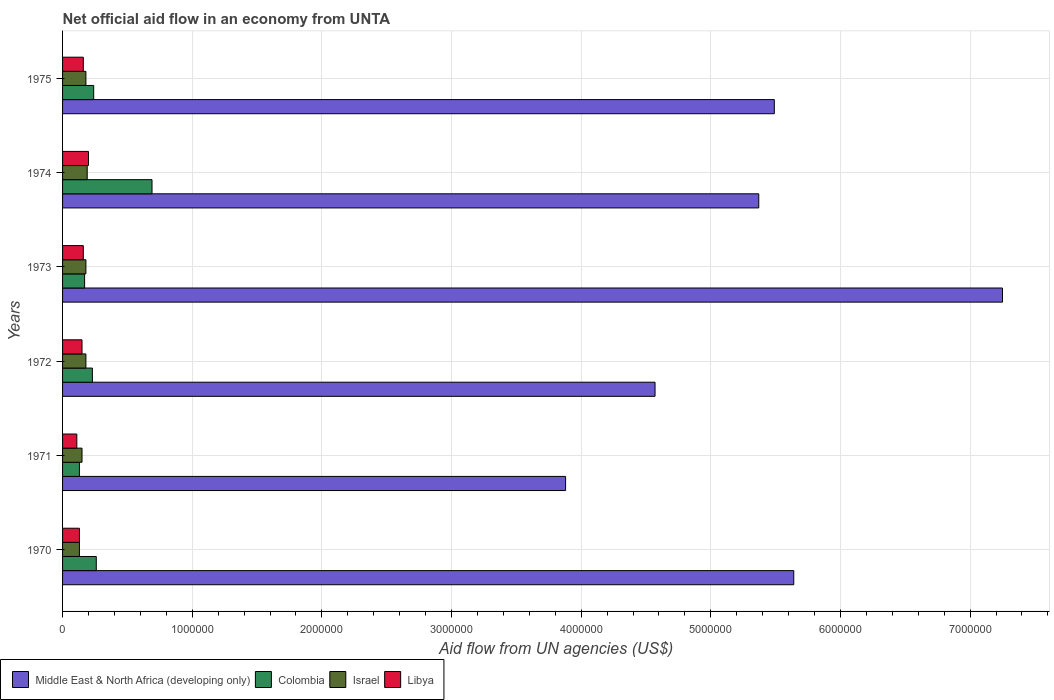Are the number of bars on each tick of the Y-axis equal?
Your response must be concise. Yes. How many bars are there on the 6th tick from the bottom?
Your response must be concise. 4. What is the net official aid flow in Israel in 1975?
Keep it short and to the point. 1.80e+05. Across all years, what is the maximum net official aid flow in Libya?
Provide a short and direct response. 2.00e+05. In which year was the net official aid flow in Libya maximum?
Make the answer very short. 1974. What is the total net official aid flow in Libya in the graph?
Offer a very short reply. 9.10e+05. What is the difference between the net official aid flow in Middle East & North Africa (developing only) in 1975 and the net official aid flow in Libya in 1972?
Your answer should be compact. 5.34e+06. What is the average net official aid flow in Middle East & North Africa (developing only) per year?
Make the answer very short. 5.37e+06. In how many years, is the net official aid flow in Colombia greater than 4200000 US$?
Offer a terse response. 0. What is the ratio of the net official aid flow in Israel in 1970 to that in 1971?
Offer a very short reply. 0.87. Is the difference between the net official aid flow in Libya in 1970 and 1972 greater than the difference between the net official aid flow in Israel in 1970 and 1972?
Make the answer very short. Yes. What is the difference between the highest and the lowest net official aid flow in Israel?
Keep it short and to the point. 6.00e+04. Is it the case that in every year, the sum of the net official aid flow in Colombia and net official aid flow in Israel is greater than the sum of net official aid flow in Middle East & North Africa (developing only) and net official aid flow in Libya?
Offer a terse response. No. What does the 4th bar from the top in 1971 represents?
Provide a succinct answer. Middle East & North Africa (developing only). What does the 4th bar from the bottom in 1974 represents?
Provide a short and direct response. Libya. Is it the case that in every year, the sum of the net official aid flow in Middle East & North Africa (developing only) and net official aid flow in Israel is greater than the net official aid flow in Colombia?
Give a very brief answer. Yes. Are all the bars in the graph horizontal?
Your answer should be compact. Yes. Are the values on the major ticks of X-axis written in scientific E-notation?
Keep it short and to the point. No. Does the graph contain any zero values?
Provide a short and direct response. No. Where does the legend appear in the graph?
Your response must be concise. Bottom left. How many legend labels are there?
Ensure brevity in your answer.  4. How are the legend labels stacked?
Provide a short and direct response. Horizontal. What is the title of the graph?
Make the answer very short. Net official aid flow in an economy from UNTA. Does "Puerto Rico" appear as one of the legend labels in the graph?
Make the answer very short. No. What is the label or title of the X-axis?
Provide a short and direct response. Aid flow from UN agencies (US$). What is the Aid flow from UN agencies (US$) in Middle East & North Africa (developing only) in 1970?
Your answer should be very brief. 5.64e+06. What is the Aid flow from UN agencies (US$) in Colombia in 1970?
Your response must be concise. 2.60e+05. What is the Aid flow from UN agencies (US$) of Libya in 1970?
Offer a terse response. 1.30e+05. What is the Aid flow from UN agencies (US$) of Middle East & North Africa (developing only) in 1971?
Offer a terse response. 3.88e+06. What is the Aid flow from UN agencies (US$) of Colombia in 1971?
Make the answer very short. 1.30e+05. What is the Aid flow from UN agencies (US$) of Middle East & North Africa (developing only) in 1972?
Offer a terse response. 4.57e+06. What is the Aid flow from UN agencies (US$) in Colombia in 1972?
Ensure brevity in your answer.  2.30e+05. What is the Aid flow from UN agencies (US$) in Israel in 1972?
Your response must be concise. 1.80e+05. What is the Aid flow from UN agencies (US$) in Middle East & North Africa (developing only) in 1973?
Your answer should be compact. 7.25e+06. What is the Aid flow from UN agencies (US$) in Colombia in 1973?
Offer a terse response. 1.70e+05. What is the Aid flow from UN agencies (US$) in Middle East & North Africa (developing only) in 1974?
Give a very brief answer. 5.37e+06. What is the Aid flow from UN agencies (US$) in Colombia in 1974?
Offer a very short reply. 6.90e+05. What is the Aid flow from UN agencies (US$) in Libya in 1974?
Give a very brief answer. 2.00e+05. What is the Aid flow from UN agencies (US$) in Middle East & North Africa (developing only) in 1975?
Your response must be concise. 5.49e+06. What is the Aid flow from UN agencies (US$) in Colombia in 1975?
Make the answer very short. 2.40e+05. What is the Aid flow from UN agencies (US$) of Libya in 1975?
Provide a short and direct response. 1.60e+05. Across all years, what is the maximum Aid flow from UN agencies (US$) in Middle East & North Africa (developing only)?
Your response must be concise. 7.25e+06. Across all years, what is the maximum Aid flow from UN agencies (US$) in Colombia?
Offer a very short reply. 6.90e+05. Across all years, what is the maximum Aid flow from UN agencies (US$) in Israel?
Give a very brief answer. 1.90e+05. Across all years, what is the minimum Aid flow from UN agencies (US$) of Middle East & North Africa (developing only)?
Offer a very short reply. 3.88e+06. Across all years, what is the minimum Aid flow from UN agencies (US$) in Israel?
Your answer should be compact. 1.30e+05. Across all years, what is the minimum Aid flow from UN agencies (US$) in Libya?
Your answer should be very brief. 1.10e+05. What is the total Aid flow from UN agencies (US$) in Middle East & North Africa (developing only) in the graph?
Offer a very short reply. 3.22e+07. What is the total Aid flow from UN agencies (US$) in Colombia in the graph?
Your response must be concise. 1.72e+06. What is the total Aid flow from UN agencies (US$) in Israel in the graph?
Your response must be concise. 1.01e+06. What is the total Aid flow from UN agencies (US$) of Libya in the graph?
Keep it short and to the point. 9.10e+05. What is the difference between the Aid flow from UN agencies (US$) of Middle East & North Africa (developing only) in 1970 and that in 1971?
Your answer should be very brief. 1.76e+06. What is the difference between the Aid flow from UN agencies (US$) in Libya in 1970 and that in 1971?
Keep it short and to the point. 2.00e+04. What is the difference between the Aid flow from UN agencies (US$) of Middle East & North Africa (developing only) in 1970 and that in 1972?
Keep it short and to the point. 1.07e+06. What is the difference between the Aid flow from UN agencies (US$) in Colombia in 1970 and that in 1972?
Provide a succinct answer. 3.00e+04. What is the difference between the Aid flow from UN agencies (US$) in Israel in 1970 and that in 1972?
Make the answer very short. -5.00e+04. What is the difference between the Aid flow from UN agencies (US$) of Libya in 1970 and that in 1972?
Ensure brevity in your answer.  -2.00e+04. What is the difference between the Aid flow from UN agencies (US$) of Middle East & North Africa (developing only) in 1970 and that in 1973?
Your answer should be very brief. -1.61e+06. What is the difference between the Aid flow from UN agencies (US$) of Colombia in 1970 and that in 1973?
Your response must be concise. 9.00e+04. What is the difference between the Aid flow from UN agencies (US$) of Libya in 1970 and that in 1973?
Your answer should be compact. -3.00e+04. What is the difference between the Aid flow from UN agencies (US$) of Middle East & North Africa (developing only) in 1970 and that in 1974?
Offer a very short reply. 2.70e+05. What is the difference between the Aid flow from UN agencies (US$) in Colombia in 1970 and that in 1974?
Your answer should be compact. -4.30e+05. What is the difference between the Aid flow from UN agencies (US$) in Israel in 1970 and that in 1974?
Your response must be concise. -6.00e+04. What is the difference between the Aid flow from UN agencies (US$) in Libya in 1970 and that in 1974?
Offer a very short reply. -7.00e+04. What is the difference between the Aid flow from UN agencies (US$) in Middle East & North Africa (developing only) in 1970 and that in 1975?
Offer a very short reply. 1.50e+05. What is the difference between the Aid flow from UN agencies (US$) in Colombia in 1970 and that in 1975?
Give a very brief answer. 2.00e+04. What is the difference between the Aid flow from UN agencies (US$) in Libya in 1970 and that in 1975?
Offer a terse response. -3.00e+04. What is the difference between the Aid flow from UN agencies (US$) of Middle East & North Africa (developing only) in 1971 and that in 1972?
Provide a succinct answer. -6.90e+05. What is the difference between the Aid flow from UN agencies (US$) of Libya in 1971 and that in 1972?
Provide a succinct answer. -4.00e+04. What is the difference between the Aid flow from UN agencies (US$) of Middle East & North Africa (developing only) in 1971 and that in 1973?
Ensure brevity in your answer.  -3.37e+06. What is the difference between the Aid flow from UN agencies (US$) of Middle East & North Africa (developing only) in 1971 and that in 1974?
Ensure brevity in your answer.  -1.49e+06. What is the difference between the Aid flow from UN agencies (US$) in Colombia in 1971 and that in 1974?
Your answer should be very brief. -5.60e+05. What is the difference between the Aid flow from UN agencies (US$) of Middle East & North Africa (developing only) in 1971 and that in 1975?
Offer a terse response. -1.61e+06. What is the difference between the Aid flow from UN agencies (US$) in Middle East & North Africa (developing only) in 1972 and that in 1973?
Make the answer very short. -2.68e+06. What is the difference between the Aid flow from UN agencies (US$) of Colombia in 1972 and that in 1973?
Ensure brevity in your answer.  6.00e+04. What is the difference between the Aid flow from UN agencies (US$) of Israel in 1972 and that in 1973?
Your answer should be compact. 0. What is the difference between the Aid flow from UN agencies (US$) in Libya in 1972 and that in 1973?
Your answer should be very brief. -10000. What is the difference between the Aid flow from UN agencies (US$) of Middle East & North Africa (developing only) in 1972 and that in 1974?
Offer a terse response. -8.00e+05. What is the difference between the Aid flow from UN agencies (US$) in Colombia in 1972 and that in 1974?
Offer a terse response. -4.60e+05. What is the difference between the Aid flow from UN agencies (US$) in Israel in 1972 and that in 1974?
Your answer should be compact. -10000. What is the difference between the Aid flow from UN agencies (US$) in Middle East & North Africa (developing only) in 1972 and that in 1975?
Offer a terse response. -9.20e+05. What is the difference between the Aid flow from UN agencies (US$) in Colombia in 1972 and that in 1975?
Give a very brief answer. -10000. What is the difference between the Aid flow from UN agencies (US$) of Middle East & North Africa (developing only) in 1973 and that in 1974?
Offer a terse response. 1.88e+06. What is the difference between the Aid flow from UN agencies (US$) in Colombia in 1973 and that in 1974?
Your answer should be very brief. -5.20e+05. What is the difference between the Aid flow from UN agencies (US$) in Libya in 1973 and that in 1974?
Give a very brief answer. -4.00e+04. What is the difference between the Aid flow from UN agencies (US$) in Middle East & North Africa (developing only) in 1973 and that in 1975?
Your response must be concise. 1.76e+06. What is the difference between the Aid flow from UN agencies (US$) in Libya in 1974 and that in 1975?
Ensure brevity in your answer.  4.00e+04. What is the difference between the Aid flow from UN agencies (US$) of Middle East & North Africa (developing only) in 1970 and the Aid flow from UN agencies (US$) of Colombia in 1971?
Offer a terse response. 5.51e+06. What is the difference between the Aid flow from UN agencies (US$) of Middle East & North Africa (developing only) in 1970 and the Aid flow from UN agencies (US$) of Israel in 1971?
Make the answer very short. 5.49e+06. What is the difference between the Aid flow from UN agencies (US$) in Middle East & North Africa (developing only) in 1970 and the Aid flow from UN agencies (US$) in Libya in 1971?
Your response must be concise. 5.53e+06. What is the difference between the Aid flow from UN agencies (US$) in Israel in 1970 and the Aid flow from UN agencies (US$) in Libya in 1971?
Your answer should be very brief. 2.00e+04. What is the difference between the Aid flow from UN agencies (US$) in Middle East & North Africa (developing only) in 1970 and the Aid flow from UN agencies (US$) in Colombia in 1972?
Give a very brief answer. 5.41e+06. What is the difference between the Aid flow from UN agencies (US$) of Middle East & North Africa (developing only) in 1970 and the Aid flow from UN agencies (US$) of Israel in 1972?
Offer a very short reply. 5.46e+06. What is the difference between the Aid flow from UN agencies (US$) in Middle East & North Africa (developing only) in 1970 and the Aid flow from UN agencies (US$) in Libya in 1972?
Your response must be concise. 5.49e+06. What is the difference between the Aid flow from UN agencies (US$) in Israel in 1970 and the Aid flow from UN agencies (US$) in Libya in 1972?
Provide a succinct answer. -2.00e+04. What is the difference between the Aid flow from UN agencies (US$) of Middle East & North Africa (developing only) in 1970 and the Aid flow from UN agencies (US$) of Colombia in 1973?
Your response must be concise. 5.47e+06. What is the difference between the Aid flow from UN agencies (US$) in Middle East & North Africa (developing only) in 1970 and the Aid flow from UN agencies (US$) in Israel in 1973?
Keep it short and to the point. 5.46e+06. What is the difference between the Aid flow from UN agencies (US$) of Middle East & North Africa (developing only) in 1970 and the Aid flow from UN agencies (US$) of Libya in 1973?
Offer a terse response. 5.48e+06. What is the difference between the Aid flow from UN agencies (US$) of Colombia in 1970 and the Aid flow from UN agencies (US$) of Libya in 1973?
Make the answer very short. 1.00e+05. What is the difference between the Aid flow from UN agencies (US$) of Middle East & North Africa (developing only) in 1970 and the Aid flow from UN agencies (US$) of Colombia in 1974?
Make the answer very short. 4.95e+06. What is the difference between the Aid flow from UN agencies (US$) of Middle East & North Africa (developing only) in 1970 and the Aid flow from UN agencies (US$) of Israel in 1974?
Offer a terse response. 5.45e+06. What is the difference between the Aid flow from UN agencies (US$) of Middle East & North Africa (developing only) in 1970 and the Aid flow from UN agencies (US$) of Libya in 1974?
Give a very brief answer. 5.44e+06. What is the difference between the Aid flow from UN agencies (US$) of Colombia in 1970 and the Aid flow from UN agencies (US$) of Libya in 1974?
Provide a short and direct response. 6.00e+04. What is the difference between the Aid flow from UN agencies (US$) of Middle East & North Africa (developing only) in 1970 and the Aid flow from UN agencies (US$) of Colombia in 1975?
Ensure brevity in your answer.  5.40e+06. What is the difference between the Aid flow from UN agencies (US$) of Middle East & North Africa (developing only) in 1970 and the Aid flow from UN agencies (US$) of Israel in 1975?
Keep it short and to the point. 5.46e+06. What is the difference between the Aid flow from UN agencies (US$) in Middle East & North Africa (developing only) in 1970 and the Aid flow from UN agencies (US$) in Libya in 1975?
Make the answer very short. 5.48e+06. What is the difference between the Aid flow from UN agencies (US$) of Colombia in 1970 and the Aid flow from UN agencies (US$) of Libya in 1975?
Your answer should be compact. 1.00e+05. What is the difference between the Aid flow from UN agencies (US$) of Israel in 1970 and the Aid flow from UN agencies (US$) of Libya in 1975?
Keep it short and to the point. -3.00e+04. What is the difference between the Aid flow from UN agencies (US$) of Middle East & North Africa (developing only) in 1971 and the Aid flow from UN agencies (US$) of Colombia in 1972?
Your answer should be compact. 3.65e+06. What is the difference between the Aid flow from UN agencies (US$) in Middle East & North Africa (developing only) in 1971 and the Aid flow from UN agencies (US$) in Israel in 1972?
Your response must be concise. 3.70e+06. What is the difference between the Aid flow from UN agencies (US$) in Middle East & North Africa (developing only) in 1971 and the Aid flow from UN agencies (US$) in Libya in 1972?
Ensure brevity in your answer.  3.73e+06. What is the difference between the Aid flow from UN agencies (US$) in Colombia in 1971 and the Aid flow from UN agencies (US$) in Israel in 1972?
Your answer should be very brief. -5.00e+04. What is the difference between the Aid flow from UN agencies (US$) in Colombia in 1971 and the Aid flow from UN agencies (US$) in Libya in 1972?
Offer a terse response. -2.00e+04. What is the difference between the Aid flow from UN agencies (US$) of Middle East & North Africa (developing only) in 1971 and the Aid flow from UN agencies (US$) of Colombia in 1973?
Provide a short and direct response. 3.71e+06. What is the difference between the Aid flow from UN agencies (US$) of Middle East & North Africa (developing only) in 1971 and the Aid flow from UN agencies (US$) of Israel in 1973?
Your answer should be very brief. 3.70e+06. What is the difference between the Aid flow from UN agencies (US$) of Middle East & North Africa (developing only) in 1971 and the Aid flow from UN agencies (US$) of Libya in 1973?
Your answer should be very brief. 3.72e+06. What is the difference between the Aid flow from UN agencies (US$) in Israel in 1971 and the Aid flow from UN agencies (US$) in Libya in 1973?
Give a very brief answer. -10000. What is the difference between the Aid flow from UN agencies (US$) in Middle East & North Africa (developing only) in 1971 and the Aid flow from UN agencies (US$) in Colombia in 1974?
Provide a succinct answer. 3.19e+06. What is the difference between the Aid flow from UN agencies (US$) of Middle East & North Africa (developing only) in 1971 and the Aid flow from UN agencies (US$) of Israel in 1974?
Provide a short and direct response. 3.69e+06. What is the difference between the Aid flow from UN agencies (US$) in Middle East & North Africa (developing only) in 1971 and the Aid flow from UN agencies (US$) in Libya in 1974?
Make the answer very short. 3.68e+06. What is the difference between the Aid flow from UN agencies (US$) in Colombia in 1971 and the Aid flow from UN agencies (US$) in Libya in 1974?
Give a very brief answer. -7.00e+04. What is the difference between the Aid flow from UN agencies (US$) in Israel in 1971 and the Aid flow from UN agencies (US$) in Libya in 1974?
Make the answer very short. -5.00e+04. What is the difference between the Aid flow from UN agencies (US$) of Middle East & North Africa (developing only) in 1971 and the Aid flow from UN agencies (US$) of Colombia in 1975?
Make the answer very short. 3.64e+06. What is the difference between the Aid flow from UN agencies (US$) of Middle East & North Africa (developing only) in 1971 and the Aid flow from UN agencies (US$) of Israel in 1975?
Give a very brief answer. 3.70e+06. What is the difference between the Aid flow from UN agencies (US$) of Middle East & North Africa (developing only) in 1971 and the Aid flow from UN agencies (US$) of Libya in 1975?
Your response must be concise. 3.72e+06. What is the difference between the Aid flow from UN agencies (US$) in Colombia in 1971 and the Aid flow from UN agencies (US$) in Libya in 1975?
Provide a short and direct response. -3.00e+04. What is the difference between the Aid flow from UN agencies (US$) in Israel in 1971 and the Aid flow from UN agencies (US$) in Libya in 1975?
Keep it short and to the point. -10000. What is the difference between the Aid flow from UN agencies (US$) in Middle East & North Africa (developing only) in 1972 and the Aid flow from UN agencies (US$) in Colombia in 1973?
Make the answer very short. 4.40e+06. What is the difference between the Aid flow from UN agencies (US$) in Middle East & North Africa (developing only) in 1972 and the Aid flow from UN agencies (US$) in Israel in 1973?
Offer a very short reply. 4.39e+06. What is the difference between the Aid flow from UN agencies (US$) of Middle East & North Africa (developing only) in 1972 and the Aid flow from UN agencies (US$) of Libya in 1973?
Offer a terse response. 4.41e+06. What is the difference between the Aid flow from UN agencies (US$) in Colombia in 1972 and the Aid flow from UN agencies (US$) in Israel in 1973?
Your answer should be very brief. 5.00e+04. What is the difference between the Aid flow from UN agencies (US$) in Colombia in 1972 and the Aid flow from UN agencies (US$) in Libya in 1973?
Offer a terse response. 7.00e+04. What is the difference between the Aid flow from UN agencies (US$) in Middle East & North Africa (developing only) in 1972 and the Aid flow from UN agencies (US$) in Colombia in 1974?
Provide a succinct answer. 3.88e+06. What is the difference between the Aid flow from UN agencies (US$) of Middle East & North Africa (developing only) in 1972 and the Aid flow from UN agencies (US$) of Israel in 1974?
Provide a succinct answer. 4.38e+06. What is the difference between the Aid flow from UN agencies (US$) of Middle East & North Africa (developing only) in 1972 and the Aid flow from UN agencies (US$) of Libya in 1974?
Make the answer very short. 4.37e+06. What is the difference between the Aid flow from UN agencies (US$) of Colombia in 1972 and the Aid flow from UN agencies (US$) of Libya in 1974?
Make the answer very short. 3.00e+04. What is the difference between the Aid flow from UN agencies (US$) of Middle East & North Africa (developing only) in 1972 and the Aid flow from UN agencies (US$) of Colombia in 1975?
Keep it short and to the point. 4.33e+06. What is the difference between the Aid flow from UN agencies (US$) in Middle East & North Africa (developing only) in 1972 and the Aid flow from UN agencies (US$) in Israel in 1975?
Provide a short and direct response. 4.39e+06. What is the difference between the Aid flow from UN agencies (US$) in Middle East & North Africa (developing only) in 1972 and the Aid flow from UN agencies (US$) in Libya in 1975?
Give a very brief answer. 4.41e+06. What is the difference between the Aid flow from UN agencies (US$) in Colombia in 1972 and the Aid flow from UN agencies (US$) in Israel in 1975?
Keep it short and to the point. 5.00e+04. What is the difference between the Aid flow from UN agencies (US$) in Colombia in 1972 and the Aid flow from UN agencies (US$) in Libya in 1975?
Keep it short and to the point. 7.00e+04. What is the difference between the Aid flow from UN agencies (US$) in Israel in 1972 and the Aid flow from UN agencies (US$) in Libya in 1975?
Offer a terse response. 2.00e+04. What is the difference between the Aid flow from UN agencies (US$) of Middle East & North Africa (developing only) in 1973 and the Aid flow from UN agencies (US$) of Colombia in 1974?
Ensure brevity in your answer.  6.56e+06. What is the difference between the Aid flow from UN agencies (US$) in Middle East & North Africa (developing only) in 1973 and the Aid flow from UN agencies (US$) in Israel in 1974?
Your response must be concise. 7.06e+06. What is the difference between the Aid flow from UN agencies (US$) of Middle East & North Africa (developing only) in 1973 and the Aid flow from UN agencies (US$) of Libya in 1974?
Give a very brief answer. 7.05e+06. What is the difference between the Aid flow from UN agencies (US$) in Colombia in 1973 and the Aid flow from UN agencies (US$) in Israel in 1974?
Give a very brief answer. -2.00e+04. What is the difference between the Aid flow from UN agencies (US$) in Colombia in 1973 and the Aid flow from UN agencies (US$) in Libya in 1974?
Keep it short and to the point. -3.00e+04. What is the difference between the Aid flow from UN agencies (US$) of Israel in 1973 and the Aid flow from UN agencies (US$) of Libya in 1974?
Offer a very short reply. -2.00e+04. What is the difference between the Aid flow from UN agencies (US$) of Middle East & North Africa (developing only) in 1973 and the Aid flow from UN agencies (US$) of Colombia in 1975?
Your answer should be very brief. 7.01e+06. What is the difference between the Aid flow from UN agencies (US$) in Middle East & North Africa (developing only) in 1973 and the Aid flow from UN agencies (US$) in Israel in 1975?
Make the answer very short. 7.07e+06. What is the difference between the Aid flow from UN agencies (US$) in Middle East & North Africa (developing only) in 1973 and the Aid flow from UN agencies (US$) in Libya in 1975?
Offer a terse response. 7.09e+06. What is the difference between the Aid flow from UN agencies (US$) in Israel in 1973 and the Aid flow from UN agencies (US$) in Libya in 1975?
Offer a terse response. 2.00e+04. What is the difference between the Aid flow from UN agencies (US$) of Middle East & North Africa (developing only) in 1974 and the Aid flow from UN agencies (US$) of Colombia in 1975?
Your answer should be very brief. 5.13e+06. What is the difference between the Aid flow from UN agencies (US$) of Middle East & North Africa (developing only) in 1974 and the Aid flow from UN agencies (US$) of Israel in 1975?
Ensure brevity in your answer.  5.19e+06. What is the difference between the Aid flow from UN agencies (US$) in Middle East & North Africa (developing only) in 1974 and the Aid flow from UN agencies (US$) in Libya in 1975?
Keep it short and to the point. 5.21e+06. What is the difference between the Aid flow from UN agencies (US$) in Colombia in 1974 and the Aid flow from UN agencies (US$) in Israel in 1975?
Your answer should be very brief. 5.10e+05. What is the difference between the Aid flow from UN agencies (US$) in Colombia in 1974 and the Aid flow from UN agencies (US$) in Libya in 1975?
Your response must be concise. 5.30e+05. What is the average Aid flow from UN agencies (US$) in Middle East & North Africa (developing only) per year?
Your response must be concise. 5.37e+06. What is the average Aid flow from UN agencies (US$) of Colombia per year?
Provide a short and direct response. 2.87e+05. What is the average Aid flow from UN agencies (US$) of Israel per year?
Provide a succinct answer. 1.68e+05. What is the average Aid flow from UN agencies (US$) in Libya per year?
Ensure brevity in your answer.  1.52e+05. In the year 1970, what is the difference between the Aid flow from UN agencies (US$) of Middle East & North Africa (developing only) and Aid flow from UN agencies (US$) of Colombia?
Provide a short and direct response. 5.38e+06. In the year 1970, what is the difference between the Aid flow from UN agencies (US$) in Middle East & North Africa (developing only) and Aid flow from UN agencies (US$) in Israel?
Your answer should be very brief. 5.51e+06. In the year 1970, what is the difference between the Aid flow from UN agencies (US$) of Middle East & North Africa (developing only) and Aid flow from UN agencies (US$) of Libya?
Your response must be concise. 5.51e+06. In the year 1970, what is the difference between the Aid flow from UN agencies (US$) of Colombia and Aid flow from UN agencies (US$) of Israel?
Your answer should be very brief. 1.30e+05. In the year 1970, what is the difference between the Aid flow from UN agencies (US$) in Colombia and Aid flow from UN agencies (US$) in Libya?
Provide a short and direct response. 1.30e+05. In the year 1970, what is the difference between the Aid flow from UN agencies (US$) of Israel and Aid flow from UN agencies (US$) of Libya?
Provide a succinct answer. 0. In the year 1971, what is the difference between the Aid flow from UN agencies (US$) in Middle East & North Africa (developing only) and Aid flow from UN agencies (US$) in Colombia?
Offer a very short reply. 3.75e+06. In the year 1971, what is the difference between the Aid flow from UN agencies (US$) of Middle East & North Africa (developing only) and Aid flow from UN agencies (US$) of Israel?
Provide a short and direct response. 3.73e+06. In the year 1971, what is the difference between the Aid flow from UN agencies (US$) of Middle East & North Africa (developing only) and Aid flow from UN agencies (US$) of Libya?
Your answer should be compact. 3.77e+06. In the year 1971, what is the difference between the Aid flow from UN agencies (US$) in Colombia and Aid flow from UN agencies (US$) in Israel?
Ensure brevity in your answer.  -2.00e+04. In the year 1971, what is the difference between the Aid flow from UN agencies (US$) in Colombia and Aid flow from UN agencies (US$) in Libya?
Your answer should be very brief. 2.00e+04. In the year 1971, what is the difference between the Aid flow from UN agencies (US$) in Israel and Aid flow from UN agencies (US$) in Libya?
Provide a short and direct response. 4.00e+04. In the year 1972, what is the difference between the Aid flow from UN agencies (US$) in Middle East & North Africa (developing only) and Aid flow from UN agencies (US$) in Colombia?
Provide a short and direct response. 4.34e+06. In the year 1972, what is the difference between the Aid flow from UN agencies (US$) of Middle East & North Africa (developing only) and Aid flow from UN agencies (US$) of Israel?
Offer a terse response. 4.39e+06. In the year 1972, what is the difference between the Aid flow from UN agencies (US$) of Middle East & North Africa (developing only) and Aid flow from UN agencies (US$) of Libya?
Your answer should be very brief. 4.42e+06. In the year 1972, what is the difference between the Aid flow from UN agencies (US$) in Colombia and Aid flow from UN agencies (US$) in Israel?
Give a very brief answer. 5.00e+04. In the year 1972, what is the difference between the Aid flow from UN agencies (US$) of Israel and Aid flow from UN agencies (US$) of Libya?
Offer a very short reply. 3.00e+04. In the year 1973, what is the difference between the Aid flow from UN agencies (US$) in Middle East & North Africa (developing only) and Aid flow from UN agencies (US$) in Colombia?
Your response must be concise. 7.08e+06. In the year 1973, what is the difference between the Aid flow from UN agencies (US$) of Middle East & North Africa (developing only) and Aid flow from UN agencies (US$) of Israel?
Make the answer very short. 7.07e+06. In the year 1973, what is the difference between the Aid flow from UN agencies (US$) in Middle East & North Africa (developing only) and Aid flow from UN agencies (US$) in Libya?
Provide a short and direct response. 7.09e+06. In the year 1973, what is the difference between the Aid flow from UN agencies (US$) in Israel and Aid flow from UN agencies (US$) in Libya?
Your answer should be very brief. 2.00e+04. In the year 1974, what is the difference between the Aid flow from UN agencies (US$) of Middle East & North Africa (developing only) and Aid flow from UN agencies (US$) of Colombia?
Give a very brief answer. 4.68e+06. In the year 1974, what is the difference between the Aid flow from UN agencies (US$) in Middle East & North Africa (developing only) and Aid flow from UN agencies (US$) in Israel?
Keep it short and to the point. 5.18e+06. In the year 1974, what is the difference between the Aid flow from UN agencies (US$) of Middle East & North Africa (developing only) and Aid flow from UN agencies (US$) of Libya?
Your answer should be very brief. 5.17e+06. In the year 1974, what is the difference between the Aid flow from UN agencies (US$) in Colombia and Aid flow from UN agencies (US$) in Israel?
Offer a terse response. 5.00e+05. In the year 1974, what is the difference between the Aid flow from UN agencies (US$) in Colombia and Aid flow from UN agencies (US$) in Libya?
Your answer should be very brief. 4.90e+05. In the year 1974, what is the difference between the Aid flow from UN agencies (US$) of Israel and Aid flow from UN agencies (US$) of Libya?
Give a very brief answer. -10000. In the year 1975, what is the difference between the Aid flow from UN agencies (US$) in Middle East & North Africa (developing only) and Aid flow from UN agencies (US$) in Colombia?
Your answer should be very brief. 5.25e+06. In the year 1975, what is the difference between the Aid flow from UN agencies (US$) in Middle East & North Africa (developing only) and Aid flow from UN agencies (US$) in Israel?
Provide a succinct answer. 5.31e+06. In the year 1975, what is the difference between the Aid flow from UN agencies (US$) in Middle East & North Africa (developing only) and Aid flow from UN agencies (US$) in Libya?
Keep it short and to the point. 5.33e+06. In the year 1975, what is the difference between the Aid flow from UN agencies (US$) in Israel and Aid flow from UN agencies (US$) in Libya?
Your answer should be very brief. 2.00e+04. What is the ratio of the Aid flow from UN agencies (US$) in Middle East & North Africa (developing only) in 1970 to that in 1971?
Give a very brief answer. 1.45. What is the ratio of the Aid flow from UN agencies (US$) of Colombia in 1970 to that in 1971?
Ensure brevity in your answer.  2. What is the ratio of the Aid flow from UN agencies (US$) in Israel in 1970 to that in 1971?
Make the answer very short. 0.87. What is the ratio of the Aid flow from UN agencies (US$) in Libya in 1970 to that in 1971?
Your answer should be compact. 1.18. What is the ratio of the Aid flow from UN agencies (US$) in Middle East & North Africa (developing only) in 1970 to that in 1972?
Your response must be concise. 1.23. What is the ratio of the Aid flow from UN agencies (US$) in Colombia in 1970 to that in 1972?
Your answer should be very brief. 1.13. What is the ratio of the Aid flow from UN agencies (US$) in Israel in 1970 to that in 1972?
Provide a succinct answer. 0.72. What is the ratio of the Aid flow from UN agencies (US$) of Libya in 1970 to that in 1972?
Offer a terse response. 0.87. What is the ratio of the Aid flow from UN agencies (US$) in Middle East & North Africa (developing only) in 1970 to that in 1973?
Provide a short and direct response. 0.78. What is the ratio of the Aid flow from UN agencies (US$) of Colombia in 1970 to that in 1973?
Offer a very short reply. 1.53. What is the ratio of the Aid flow from UN agencies (US$) of Israel in 1970 to that in 1973?
Offer a terse response. 0.72. What is the ratio of the Aid flow from UN agencies (US$) of Libya in 1970 to that in 1973?
Your response must be concise. 0.81. What is the ratio of the Aid flow from UN agencies (US$) in Middle East & North Africa (developing only) in 1970 to that in 1974?
Offer a very short reply. 1.05. What is the ratio of the Aid flow from UN agencies (US$) in Colombia in 1970 to that in 1974?
Give a very brief answer. 0.38. What is the ratio of the Aid flow from UN agencies (US$) in Israel in 1970 to that in 1974?
Your response must be concise. 0.68. What is the ratio of the Aid flow from UN agencies (US$) of Libya in 1970 to that in 1974?
Give a very brief answer. 0.65. What is the ratio of the Aid flow from UN agencies (US$) in Middle East & North Africa (developing only) in 1970 to that in 1975?
Offer a terse response. 1.03. What is the ratio of the Aid flow from UN agencies (US$) of Colombia in 1970 to that in 1975?
Make the answer very short. 1.08. What is the ratio of the Aid flow from UN agencies (US$) of Israel in 1970 to that in 1975?
Provide a succinct answer. 0.72. What is the ratio of the Aid flow from UN agencies (US$) of Libya in 1970 to that in 1975?
Give a very brief answer. 0.81. What is the ratio of the Aid flow from UN agencies (US$) in Middle East & North Africa (developing only) in 1971 to that in 1972?
Your answer should be compact. 0.85. What is the ratio of the Aid flow from UN agencies (US$) of Colombia in 1971 to that in 1972?
Offer a very short reply. 0.57. What is the ratio of the Aid flow from UN agencies (US$) in Libya in 1971 to that in 1972?
Provide a succinct answer. 0.73. What is the ratio of the Aid flow from UN agencies (US$) in Middle East & North Africa (developing only) in 1971 to that in 1973?
Make the answer very short. 0.54. What is the ratio of the Aid flow from UN agencies (US$) in Colombia in 1971 to that in 1973?
Your response must be concise. 0.76. What is the ratio of the Aid flow from UN agencies (US$) in Libya in 1971 to that in 1973?
Provide a succinct answer. 0.69. What is the ratio of the Aid flow from UN agencies (US$) of Middle East & North Africa (developing only) in 1971 to that in 1974?
Keep it short and to the point. 0.72. What is the ratio of the Aid flow from UN agencies (US$) in Colombia in 1971 to that in 1974?
Offer a very short reply. 0.19. What is the ratio of the Aid flow from UN agencies (US$) in Israel in 1971 to that in 1974?
Offer a very short reply. 0.79. What is the ratio of the Aid flow from UN agencies (US$) in Libya in 1971 to that in 1974?
Give a very brief answer. 0.55. What is the ratio of the Aid flow from UN agencies (US$) of Middle East & North Africa (developing only) in 1971 to that in 1975?
Your response must be concise. 0.71. What is the ratio of the Aid flow from UN agencies (US$) of Colombia in 1971 to that in 1975?
Your response must be concise. 0.54. What is the ratio of the Aid flow from UN agencies (US$) in Libya in 1971 to that in 1975?
Offer a terse response. 0.69. What is the ratio of the Aid flow from UN agencies (US$) of Middle East & North Africa (developing only) in 1972 to that in 1973?
Offer a very short reply. 0.63. What is the ratio of the Aid flow from UN agencies (US$) in Colombia in 1972 to that in 1973?
Make the answer very short. 1.35. What is the ratio of the Aid flow from UN agencies (US$) in Libya in 1972 to that in 1973?
Provide a succinct answer. 0.94. What is the ratio of the Aid flow from UN agencies (US$) in Middle East & North Africa (developing only) in 1972 to that in 1974?
Your response must be concise. 0.85. What is the ratio of the Aid flow from UN agencies (US$) of Israel in 1972 to that in 1974?
Offer a terse response. 0.95. What is the ratio of the Aid flow from UN agencies (US$) in Middle East & North Africa (developing only) in 1972 to that in 1975?
Make the answer very short. 0.83. What is the ratio of the Aid flow from UN agencies (US$) of Colombia in 1972 to that in 1975?
Your answer should be compact. 0.96. What is the ratio of the Aid flow from UN agencies (US$) in Israel in 1972 to that in 1975?
Your answer should be very brief. 1. What is the ratio of the Aid flow from UN agencies (US$) of Libya in 1972 to that in 1975?
Ensure brevity in your answer.  0.94. What is the ratio of the Aid flow from UN agencies (US$) of Middle East & North Africa (developing only) in 1973 to that in 1974?
Make the answer very short. 1.35. What is the ratio of the Aid flow from UN agencies (US$) of Colombia in 1973 to that in 1974?
Keep it short and to the point. 0.25. What is the ratio of the Aid flow from UN agencies (US$) of Libya in 1973 to that in 1974?
Your answer should be very brief. 0.8. What is the ratio of the Aid flow from UN agencies (US$) in Middle East & North Africa (developing only) in 1973 to that in 1975?
Your answer should be compact. 1.32. What is the ratio of the Aid flow from UN agencies (US$) of Colombia in 1973 to that in 1975?
Your answer should be very brief. 0.71. What is the ratio of the Aid flow from UN agencies (US$) in Israel in 1973 to that in 1975?
Your answer should be very brief. 1. What is the ratio of the Aid flow from UN agencies (US$) in Middle East & North Africa (developing only) in 1974 to that in 1975?
Give a very brief answer. 0.98. What is the ratio of the Aid flow from UN agencies (US$) in Colombia in 1974 to that in 1975?
Ensure brevity in your answer.  2.88. What is the ratio of the Aid flow from UN agencies (US$) in Israel in 1974 to that in 1975?
Ensure brevity in your answer.  1.06. What is the difference between the highest and the second highest Aid flow from UN agencies (US$) in Middle East & North Africa (developing only)?
Your response must be concise. 1.61e+06. What is the difference between the highest and the second highest Aid flow from UN agencies (US$) of Colombia?
Offer a terse response. 4.30e+05. What is the difference between the highest and the second highest Aid flow from UN agencies (US$) of Israel?
Keep it short and to the point. 10000. What is the difference between the highest and the second highest Aid flow from UN agencies (US$) of Libya?
Provide a short and direct response. 4.00e+04. What is the difference between the highest and the lowest Aid flow from UN agencies (US$) in Middle East & North Africa (developing only)?
Give a very brief answer. 3.37e+06. What is the difference between the highest and the lowest Aid flow from UN agencies (US$) of Colombia?
Offer a terse response. 5.60e+05. What is the difference between the highest and the lowest Aid flow from UN agencies (US$) of Libya?
Ensure brevity in your answer.  9.00e+04. 